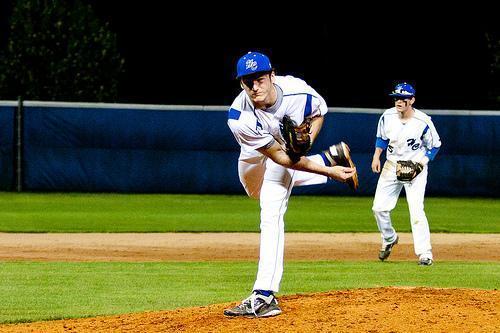How many pitchers are there?
Give a very brief answer. 1. 